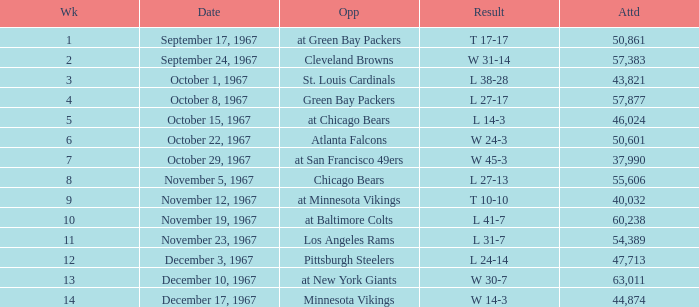Which Date has a Week smaller than 8, and an Opponent of atlanta falcons? October 22, 1967. 